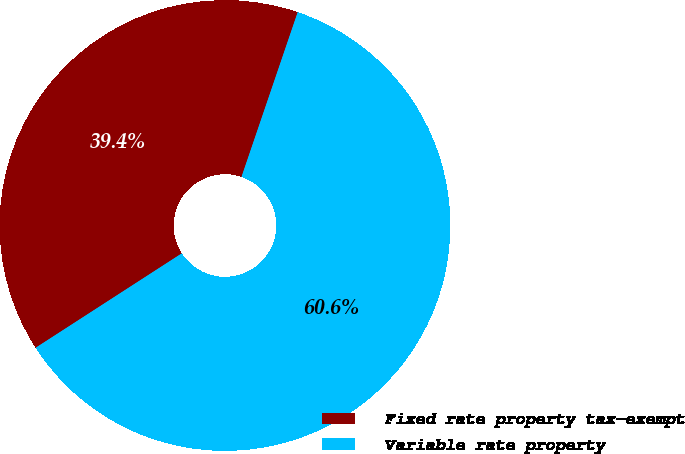Convert chart. <chart><loc_0><loc_0><loc_500><loc_500><pie_chart><fcel>Fixed rate property tax-exempt<fcel>Variable rate property<nl><fcel>39.36%<fcel>60.64%<nl></chart> 